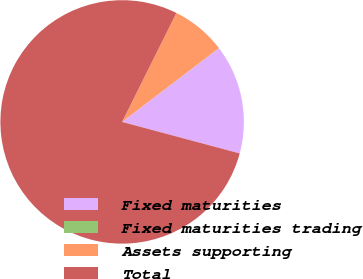Convert chart. <chart><loc_0><loc_0><loc_500><loc_500><pie_chart><fcel>Fixed maturities<fcel>Fixed maturities trading<fcel>Assets supporting<fcel>Total<nl><fcel>14.52%<fcel>0.02%<fcel>7.27%<fcel>78.19%<nl></chart> 